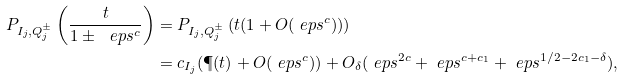<formula> <loc_0><loc_0><loc_500><loc_500>P _ { I _ { j } , Q _ { j } ^ { \pm } } \left ( \frac { t } { 1 \pm \ e p s ^ { c } } \right ) & = P _ { I _ { j } , Q _ { j } ^ { \pm } } \left ( t ( 1 + O ( \ e p s ^ { c } ) ) \right ) \\ & = c _ { I _ { j } } ( \P ( t ) + O ( \ e p s ^ { c } ) ) + O _ { \delta } ( \ e p s ^ { 2 c } + \ e p s ^ { c + c _ { 1 } } + \ e p s ^ { 1 / 2 - 2 c _ { 1 } - \delta } ) ,</formula> 